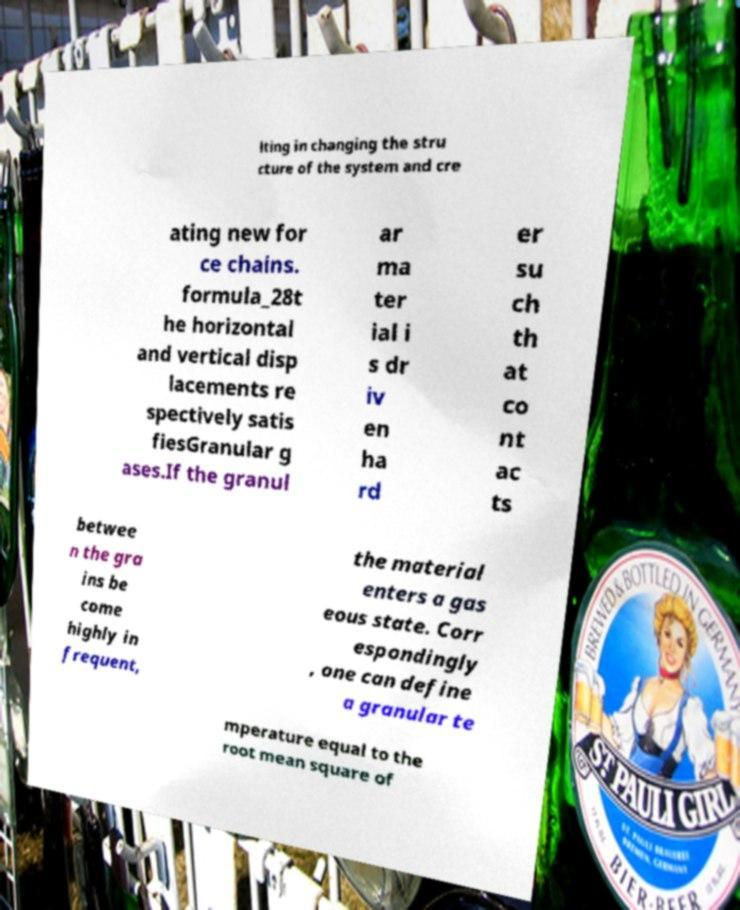Could you extract and type out the text from this image? lting in changing the stru cture of the system and cre ating new for ce chains. formula_28t he horizontal and vertical disp lacements re spectively satis fiesGranular g ases.If the granul ar ma ter ial i s dr iv en ha rd er su ch th at co nt ac ts betwee n the gra ins be come highly in frequent, the material enters a gas eous state. Corr espondingly , one can define a granular te mperature equal to the root mean square of 